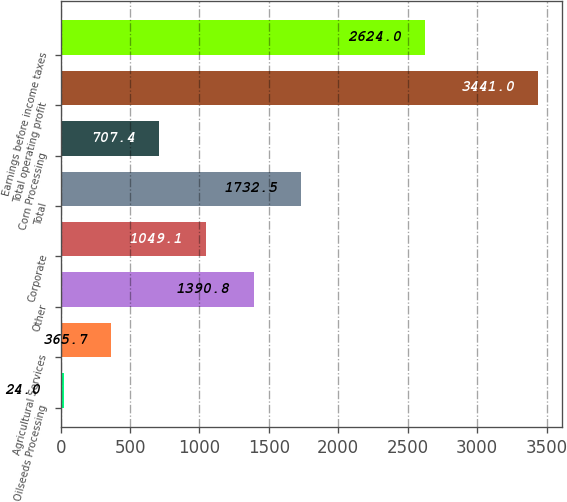Convert chart to OTSL. <chart><loc_0><loc_0><loc_500><loc_500><bar_chart><fcel>Oilseeds Processing<fcel>Agricultural Services<fcel>Other<fcel>Corporate<fcel>Total<fcel>Corn Processing<fcel>Total operating profit<fcel>Earnings before income taxes<nl><fcel>24<fcel>365.7<fcel>1390.8<fcel>1049.1<fcel>1732.5<fcel>707.4<fcel>3441<fcel>2624<nl></chart> 